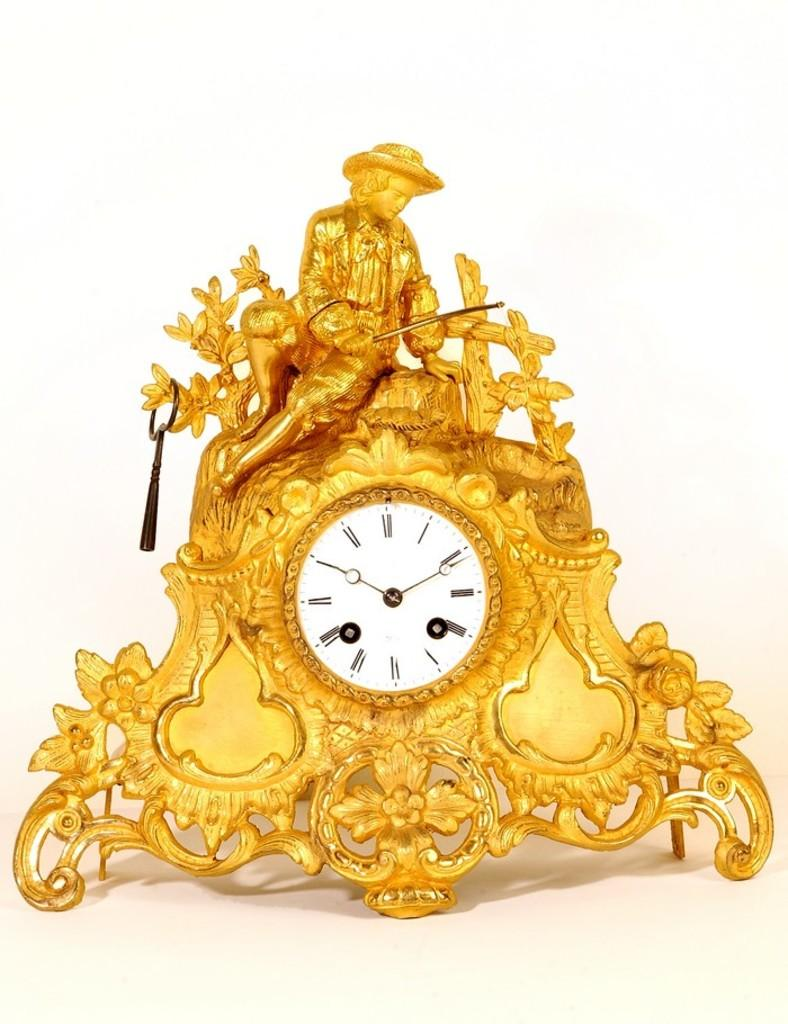<image>
Offer a succinct explanation of the picture presented. A golden clock with a boy fishing carved into it is showing the time 10:11. 